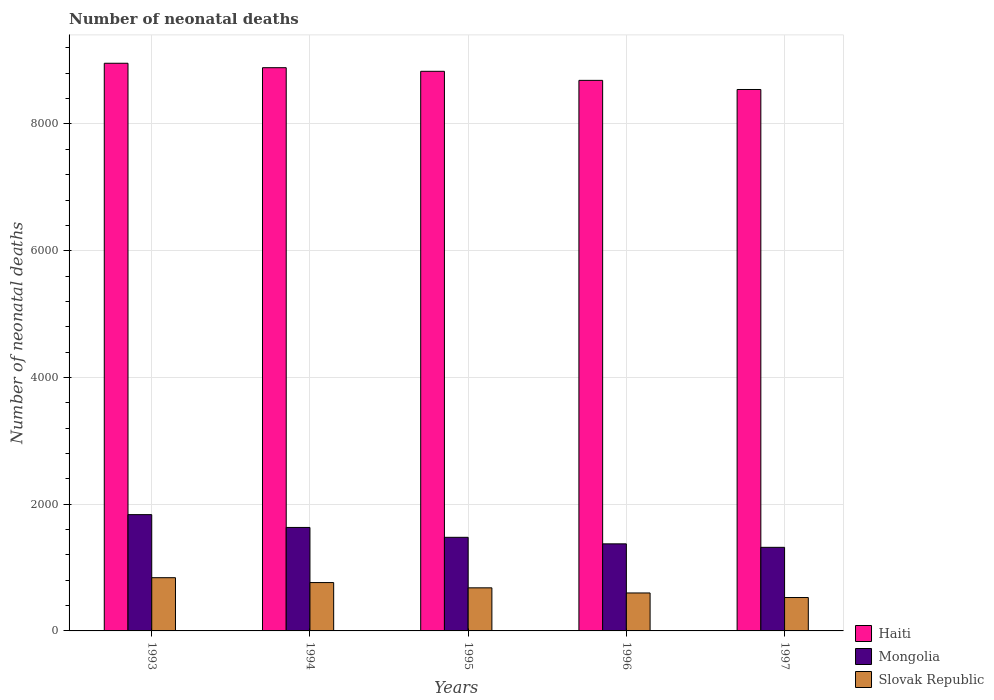How many groups of bars are there?
Offer a terse response. 5. How many bars are there on the 4th tick from the left?
Your answer should be compact. 3. How many bars are there on the 1st tick from the right?
Keep it short and to the point. 3. In how many cases, is the number of bars for a given year not equal to the number of legend labels?
Offer a terse response. 0. What is the number of neonatal deaths in in Mongolia in 1997?
Give a very brief answer. 1319. Across all years, what is the maximum number of neonatal deaths in in Haiti?
Provide a succinct answer. 8958. Across all years, what is the minimum number of neonatal deaths in in Haiti?
Make the answer very short. 8544. In which year was the number of neonatal deaths in in Mongolia minimum?
Your answer should be compact. 1997. What is the total number of neonatal deaths in in Slovak Republic in the graph?
Your response must be concise. 3409. What is the difference between the number of neonatal deaths in in Slovak Republic in 1993 and that in 1997?
Your answer should be very brief. 313. What is the difference between the number of neonatal deaths in in Haiti in 1996 and the number of neonatal deaths in in Mongolia in 1994?
Provide a succinct answer. 7055. What is the average number of neonatal deaths in in Haiti per year?
Give a very brief answer. 8781.8. In the year 1997, what is the difference between the number of neonatal deaths in in Mongolia and number of neonatal deaths in in Haiti?
Your response must be concise. -7225. In how many years, is the number of neonatal deaths in in Haiti greater than 8400?
Your response must be concise. 5. What is the ratio of the number of neonatal deaths in in Haiti in 1994 to that in 1996?
Offer a very short reply. 1.02. What is the difference between the highest and the second highest number of neonatal deaths in in Mongolia?
Provide a succinct answer. 202. What is the difference between the highest and the lowest number of neonatal deaths in in Slovak Republic?
Keep it short and to the point. 313. Is the sum of the number of neonatal deaths in in Mongolia in 1994 and 1997 greater than the maximum number of neonatal deaths in in Haiti across all years?
Your response must be concise. No. What does the 3rd bar from the left in 1995 represents?
Provide a short and direct response. Slovak Republic. What does the 2nd bar from the right in 1996 represents?
Provide a short and direct response. Mongolia. How many bars are there?
Make the answer very short. 15. How many years are there in the graph?
Keep it short and to the point. 5. What is the difference between two consecutive major ticks on the Y-axis?
Ensure brevity in your answer.  2000. Are the values on the major ticks of Y-axis written in scientific E-notation?
Offer a terse response. No. Does the graph contain grids?
Your answer should be very brief. Yes. How are the legend labels stacked?
Provide a succinct answer. Vertical. What is the title of the graph?
Provide a short and direct response. Number of neonatal deaths. Does "Honduras" appear as one of the legend labels in the graph?
Offer a terse response. No. What is the label or title of the Y-axis?
Make the answer very short. Number of neonatal deaths. What is the Number of neonatal deaths of Haiti in 1993?
Your answer should be very brief. 8958. What is the Number of neonatal deaths in Mongolia in 1993?
Provide a short and direct response. 1835. What is the Number of neonatal deaths in Slovak Republic in 1993?
Offer a very short reply. 840. What is the Number of neonatal deaths in Haiti in 1994?
Provide a short and direct response. 8888. What is the Number of neonatal deaths of Mongolia in 1994?
Offer a very short reply. 1633. What is the Number of neonatal deaths in Slovak Republic in 1994?
Provide a short and direct response. 763. What is the Number of neonatal deaths in Haiti in 1995?
Provide a succinct answer. 8831. What is the Number of neonatal deaths of Mongolia in 1995?
Offer a terse response. 1477. What is the Number of neonatal deaths in Slovak Republic in 1995?
Your answer should be very brief. 680. What is the Number of neonatal deaths of Haiti in 1996?
Your response must be concise. 8688. What is the Number of neonatal deaths in Mongolia in 1996?
Offer a very short reply. 1374. What is the Number of neonatal deaths in Slovak Republic in 1996?
Make the answer very short. 599. What is the Number of neonatal deaths in Haiti in 1997?
Provide a short and direct response. 8544. What is the Number of neonatal deaths of Mongolia in 1997?
Provide a succinct answer. 1319. What is the Number of neonatal deaths of Slovak Republic in 1997?
Make the answer very short. 527. Across all years, what is the maximum Number of neonatal deaths of Haiti?
Your answer should be compact. 8958. Across all years, what is the maximum Number of neonatal deaths of Mongolia?
Your answer should be compact. 1835. Across all years, what is the maximum Number of neonatal deaths of Slovak Republic?
Your answer should be very brief. 840. Across all years, what is the minimum Number of neonatal deaths of Haiti?
Keep it short and to the point. 8544. Across all years, what is the minimum Number of neonatal deaths of Mongolia?
Give a very brief answer. 1319. Across all years, what is the minimum Number of neonatal deaths of Slovak Republic?
Provide a succinct answer. 527. What is the total Number of neonatal deaths of Haiti in the graph?
Make the answer very short. 4.39e+04. What is the total Number of neonatal deaths of Mongolia in the graph?
Ensure brevity in your answer.  7638. What is the total Number of neonatal deaths in Slovak Republic in the graph?
Your answer should be very brief. 3409. What is the difference between the Number of neonatal deaths in Mongolia in 1993 and that in 1994?
Your response must be concise. 202. What is the difference between the Number of neonatal deaths in Haiti in 1993 and that in 1995?
Offer a very short reply. 127. What is the difference between the Number of neonatal deaths of Mongolia in 1993 and that in 1995?
Ensure brevity in your answer.  358. What is the difference between the Number of neonatal deaths of Slovak Republic in 1993 and that in 1995?
Your response must be concise. 160. What is the difference between the Number of neonatal deaths in Haiti in 1993 and that in 1996?
Make the answer very short. 270. What is the difference between the Number of neonatal deaths in Mongolia in 1993 and that in 1996?
Your response must be concise. 461. What is the difference between the Number of neonatal deaths in Slovak Republic in 1993 and that in 1996?
Provide a succinct answer. 241. What is the difference between the Number of neonatal deaths in Haiti in 1993 and that in 1997?
Your answer should be compact. 414. What is the difference between the Number of neonatal deaths of Mongolia in 1993 and that in 1997?
Make the answer very short. 516. What is the difference between the Number of neonatal deaths in Slovak Republic in 1993 and that in 1997?
Provide a succinct answer. 313. What is the difference between the Number of neonatal deaths of Mongolia in 1994 and that in 1995?
Offer a terse response. 156. What is the difference between the Number of neonatal deaths in Mongolia in 1994 and that in 1996?
Offer a very short reply. 259. What is the difference between the Number of neonatal deaths of Slovak Republic in 1994 and that in 1996?
Ensure brevity in your answer.  164. What is the difference between the Number of neonatal deaths in Haiti in 1994 and that in 1997?
Your answer should be very brief. 344. What is the difference between the Number of neonatal deaths of Mongolia in 1994 and that in 1997?
Your response must be concise. 314. What is the difference between the Number of neonatal deaths of Slovak Republic in 1994 and that in 1997?
Ensure brevity in your answer.  236. What is the difference between the Number of neonatal deaths in Haiti in 1995 and that in 1996?
Your response must be concise. 143. What is the difference between the Number of neonatal deaths of Mongolia in 1995 and that in 1996?
Ensure brevity in your answer.  103. What is the difference between the Number of neonatal deaths of Haiti in 1995 and that in 1997?
Provide a short and direct response. 287. What is the difference between the Number of neonatal deaths of Mongolia in 1995 and that in 1997?
Offer a terse response. 158. What is the difference between the Number of neonatal deaths of Slovak Republic in 1995 and that in 1997?
Offer a terse response. 153. What is the difference between the Number of neonatal deaths of Haiti in 1996 and that in 1997?
Your answer should be compact. 144. What is the difference between the Number of neonatal deaths in Mongolia in 1996 and that in 1997?
Your answer should be compact. 55. What is the difference between the Number of neonatal deaths of Haiti in 1993 and the Number of neonatal deaths of Mongolia in 1994?
Offer a terse response. 7325. What is the difference between the Number of neonatal deaths of Haiti in 1993 and the Number of neonatal deaths of Slovak Republic in 1994?
Offer a very short reply. 8195. What is the difference between the Number of neonatal deaths of Mongolia in 1993 and the Number of neonatal deaths of Slovak Republic in 1994?
Offer a terse response. 1072. What is the difference between the Number of neonatal deaths in Haiti in 1993 and the Number of neonatal deaths in Mongolia in 1995?
Provide a succinct answer. 7481. What is the difference between the Number of neonatal deaths in Haiti in 1993 and the Number of neonatal deaths in Slovak Republic in 1995?
Keep it short and to the point. 8278. What is the difference between the Number of neonatal deaths in Mongolia in 1993 and the Number of neonatal deaths in Slovak Republic in 1995?
Offer a very short reply. 1155. What is the difference between the Number of neonatal deaths in Haiti in 1993 and the Number of neonatal deaths in Mongolia in 1996?
Offer a very short reply. 7584. What is the difference between the Number of neonatal deaths in Haiti in 1993 and the Number of neonatal deaths in Slovak Republic in 1996?
Offer a terse response. 8359. What is the difference between the Number of neonatal deaths of Mongolia in 1993 and the Number of neonatal deaths of Slovak Republic in 1996?
Ensure brevity in your answer.  1236. What is the difference between the Number of neonatal deaths in Haiti in 1993 and the Number of neonatal deaths in Mongolia in 1997?
Provide a short and direct response. 7639. What is the difference between the Number of neonatal deaths in Haiti in 1993 and the Number of neonatal deaths in Slovak Republic in 1997?
Give a very brief answer. 8431. What is the difference between the Number of neonatal deaths of Mongolia in 1993 and the Number of neonatal deaths of Slovak Republic in 1997?
Provide a short and direct response. 1308. What is the difference between the Number of neonatal deaths of Haiti in 1994 and the Number of neonatal deaths of Mongolia in 1995?
Your response must be concise. 7411. What is the difference between the Number of neonatal deaths of Haiti in 1994 and the Number of neonatal deaths of Slovak Republic in 1995?
Your answer should be very brief. 8208. What is the difference between the Number of neonatal deaths in Mongolia in 1994 and the Number of neonatal deaths in Slovak Republic in 1995?
Make the answer very short. 953. What is the difference between the Number of neonatal deaths of Haiti in 1994 and the Number of neonatal deaths of Mongolia in 1996?
Your answer should be compact. 7514. What is the difference between the Number of neonatal deaths of Haiti in 1994 and the Number of neonatal deaths of Slovak Republic in 1996?
Your response must be concise. 8289. What is the difference between the Number of neonatal deaths in Mongolia in 1994 and the Number of neonatal deaths in Slovak Republic in 1996?
Give a very brief answer. 1034. What is the difference between the Number of neonatal deaths in Haiti in 1994 and the Number of neonatal deaths in Mongolia in 1997?
Your response must be concise. 7569. What is the difference between the Number of neonatal deaths in Haiti in 1994 and the Number of neonatal deaths in Slovak Republic in 1997?
Your response must be concise. 8361. What is the difference between the Number of neonatal deaths of Mongolia in 1994 and the Number of neonatal deaths of Slovak Republic in 1997?
Provide a short and direct response. 1106. What is the difference between the Number of neonatal deaths of Haiti in 1995 and the Number of neonatal deaths of Mongolia in 1996?
Your answer should be very brief. 7457. What is the difference between the Number of neonatal deaths in Haiti in 1995 and the Number of neonatal deaths in Slovak Republic in 1996?
Give a very brief answer. 8232. What is the difference between the Number of neonatal deaths of Mongolia in 1995 and the Number of neonatal deaths of Slovak Republic in 1996?
Offer a terse response. 878. What is the difference between the Number of neonatal deaths of Haiti in 1995 and the Number of neonatal deaths of Mongolia in 1997?
Your answer should be compact. 7512. What is the difference between the Number of neonatal deaths in Haiti in 1995 and the Number of neonatal deaths in Slovak Republic in 1997?
Your response must be concise. 8304. What is the difference between the Number of neonatal deaths of Mongolia in 1995 and the Number of neonatal deaths of Slovak Republic in 1997?
Keep it short and to the point. 950. What is the difference between the Number of neonatal deaths in Haiti in 1996 and the Number of neonatal deaths in Mongolia in 1997?
Ensure brevity in your answer.  7369. What is the difference between the Number of neonatal deaths of Haiti in 1996 and the Number of neonatal deaths of Slovak Republic in 1997?
Make the answer very short. 8161. What is the difference between the Number of neonatal deaths in Mongolia in 1996 and the Number of neonatal deaths in Slovak Republic in 1997?
Make the answer very short. 847. What is the average Number of neonatal deaths in Haiti per year?
Offer a terse response. 8781.8. What is the average Number of neonatal deaths in Mongolia per year?
Make the answer very short. 1527.6. What is the average Number of neonatal deaths in Slovak Republic per year?
Provide a short and direct response. 681.8. In the year 1993, what is the difference between the Number of neonatal deaths of Haiti and Number of neonatal deaths of Mongolia?
Make the answer very short. 7123. In the year 1993, what is the difference between the Number of neonatal deaths in Haiti and Number of neonatal deaths in Slovak Republic?
Your response must be concise. 8118. In the year 1993, what is the difference between the Number of neonatal deaths in Mongolia and Number of neonatal deaths in Slovak Republic?
Provide a short and direct response. 995. In the year 1994, what is the difference between the Number of neonatal deaths in Haiti and Number of neonatal deaths in Mongolia?
Provide a succinct answer. 7255. In the year 1994, what is the difference between the Number of neonatal deaths in Haiti and Number of neonatal deaths in Slovak Republic?
Provide a succinct answer. 8125. In the year 1994, what is the difference between the Number of neonatal deaths of Mongolia and Number of neonatal deaths of Slovak Republic?
Your response must be concise. 870. In the year 1995, what is the difference between the Number of neonatal deaths in Haiti and Number of neonatal deaths in Mongolia?
Your answer should be compact. 7354. In the year 1995, what is the difference between the Number of neonatal deaths of Haiti and Number of neonatal deaths of Slovak Republic?
Your response must be concise. 8151. In the year 1995, what is the difference between the Number of neonatal deaths of Mongolia and Number of neonatal deaths of Slovak Republic?
Your response must be concise. 797. In the year 1996, what is the difference between the Number of neonatal deaths in Haiti and Number of neonatal deaths in Mongolia?
Your answer should be compact. 7314. In the year 1996, what is the difference between the Number of neonatal deaths of Haiti and Number of neonatal deaths of Slovak Republic?
Keep it short and to the point. 8089. In the year 1996, what is the difference between the Number of neonatal deaths in Mongolia and Number of neonatal deaths in Slovak Republic?
Ensure brevity in your answer.  775. In the year 1997, what is the difference between the Number of neonatal deaths of Haiti and Number of neonatal deaths of Mongolia?
Keep it short and to the point. 7225. In the year 1997, what is the difference between the Number of neonatal deaths in Haiti and Number of neonatal deaths in Slovak Republic?
Your answer should be very brief. 8017. In the year 1997, what is the difference between the Number of neonatal deaths in Mongolia and Number of neonatal deaths in Slovak Republic?
Give a very brief answer. 792. What is the ratio of the Number of neonatal deaths of Haiti in 1993 to that in 1994?
Ensure brevity in your answer.  1.01. What is the ratio of the Number of neonatal deaths in Mongolia in 1993 to that in 1994?
Your answer should be compact. 1.12. What is the ratio of the Number of neonatal deaths of Slovak Republic in 1993 to that in 1994?
Your answer should be compact. 1.1. What is the ratio of the Number of neonatal deaths in Haiti in 1993 to that in 1995?
Your answer should be very brief. 1.01. What is the ratio of the Number of neonatal deaths in Mongolia in 1993 to that in 1995?
Keep it short and to the point. 1.24. What is the ratio of the Number of neonatal deaths of Slovak Republic in 1993 to that in 1995?
Make the answer very short. 1.24. What is the ratio of the Number of neonatal deaths in Haiti in 1993 to that in 1996?
Keep it short and to the point. 1.03. What is the ratio of the Number of neonatal deaths of Mongolia in 1993 to that in 1996?
Your answer should be very brief. 1.34. What is the ratio of the Number of neonatal deaths of Slovak Republic in 1993 to that in 1996?
Your answer should be compact. 1.4. What is the ratio of the Number of neonatal deaths of Haiti in 1993 to that in 1997?
Ensure brevity in your answer.  1.05. What is the ratio of the Number of neonatal deaths in Mongolia in 1993 to that in 1997?
Provide a succinct answer. 1.39. What is the ratio of the Number of neonatal deaths in Slovak Republic in 1993 to that in 1997?
Provide a short and direct response. 1.59. What is the ratio of the Number of neonatal deaths in Haiti in 1994 to that in 1995?
Provide a short and direct response. 1.01. What is the ratio of the Number of neonatal deaths in Mongolia in 1994 to that in 1995?
Provide a succinct answer. 1.11. What is the ratio of the Number of neonatal deaths in Slovak Republic in 1994 to that in 1995?
Your answer should be compact. 1.12. What is the ratio of the Number of neonatal deaths in Haiti in 1994 to that in 1996?
Make the answer very short. 1.02. What is the ratio of the Number of neonatal deaths in Mongolia in 1994 to that in 1996?
Offer a terse response. 1.19. What is the ratio of the Number of neonatal deaths in Slovak Republic in 1994 to that in 1996?
Ensure brevity in your answer.  1.27. What is the ratio of the Number of neonatal deaths in Haiti in 1994 to that in 1997?
Give a very brief answer. 1.04. What is the ratio of the Number of neonatal deaths of Mongolia in 1994 to that in 1997?
Give a very brief answer. 1.24. What is the ratio of the Number of neonatal deaths in Slovak Republic in 1994 to that in 1997?
Make the answer very short. 1.45. What is the ratio of the Number of neonatal deaths of Haiti in 1995 to that in 1996?
Ensure brevity in your answer.  1.02. What is the ratio of the Number of neonatal deaths in Mongolia in 1995 to that in 1996?
Ensure brevity in your answer.  1.07. What is the ratio of the Number of neonatal deaths in Slovak Republic in 1995 to that in 1996?
Provide a succinct answer. 1.14. What is the ratio of the Number of neonatal deaths of Haiti in 1995 to that in 1997?
Ensure brevity in your answer.  1.03. What is the ratio of the Number of neonatal deaths in Mongolia in 1995 to that in 1997?
Provide a succinct answer. 1.12. What is the ratio of the Number of neonatal deaths of Slovak Republic in 1995 to that in 1997?
Provide a succinct answer. 1.29. What is the ratio of the Number of neonatal deaths in Haiti in 1996 to that in 1997?
Your response must be concise. 1.02. What is the ratio of the Number of neonatal deaths of Mongolia in 1996 to that in 1997?
Your answer should be very brief. 1.04. What is the ratio of the Number of neonatal deaths in Slovak Republic in 1996 to that in 1997?
Provide a short and direct response. 1.14. What is the difference between the highest and the second highest Number of neonatal deaths in Haiti?
Provide a short and direct response. 70. What is the difference between the highest and the second highest Number of neonatal deaths in Mongolia?
Your answer should be compact. 202. What is the difference between the highest and the second highest Number of neonatal deaths of Slovak Republic?
Ensure brevity in your answer.  77. What is the difference between the highest and the lowest Number of neonatal deaths of Haiti?
Offer a terse response. 414. What is the difference between the highest and the lowest Number of neonatal deaths in Mongolia?
Your answer should be compact. 516. What is the difference between the highest and the lowest Number of neonatal deaths in Slovak Republic?
Your response must be concise. 313. 